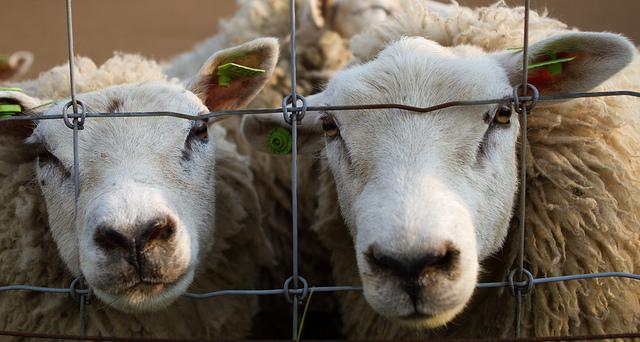Are these two dogs?
Write a very short answer. No. Are both sheep's ears tagged?
Quick response, please. Yes. Are the sheep running around in the wild?
Write a very short answer. No. 